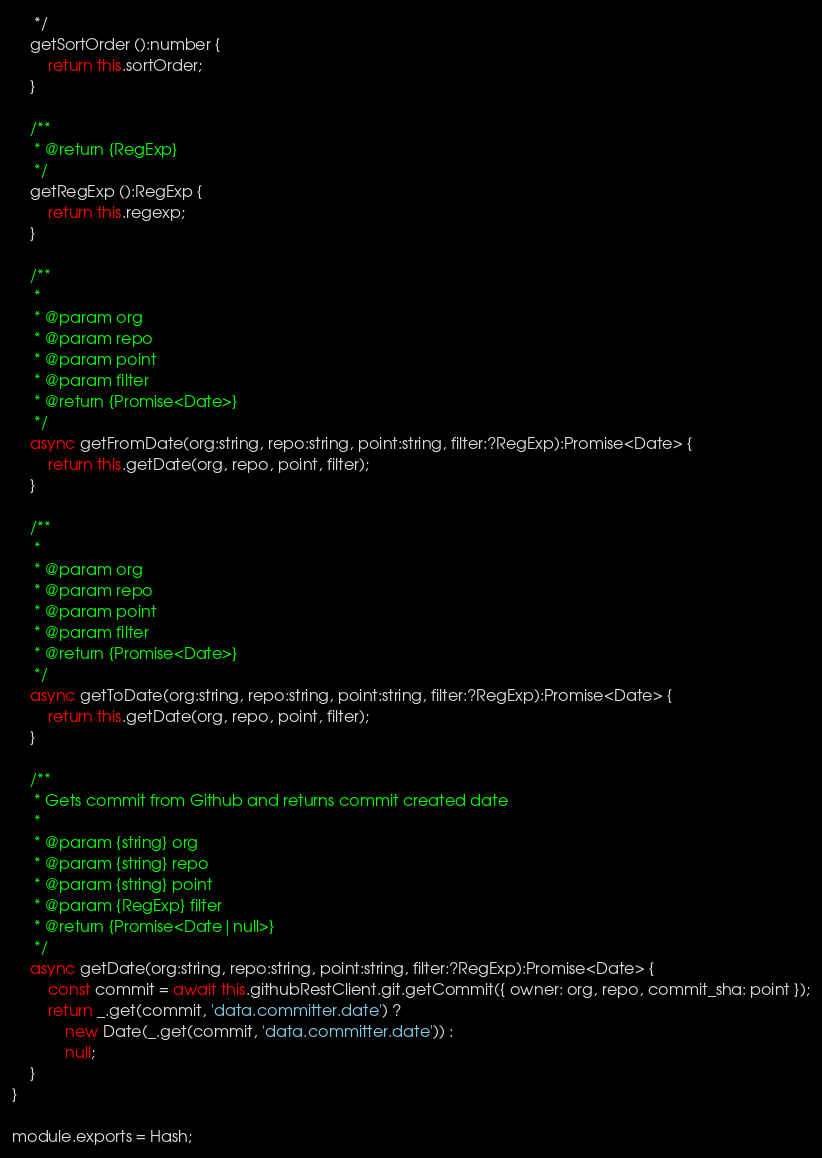<code> <loc_0><loc_0><loc_500><loc_500><_JavaScript_>     */
    getSortOrder ():number {
    	return this.sortOrder;
    }

    /**
     * @return {RegExp}
     */
    getRegExp ():RegExp {
    	return this.regexp;
    }

    /**
     *
     * @param org
     * @param repo
     * @param point
     * @param filter
     * @return {Promise<Date>}
     */
    async getFromDate(org:string, repo:string, point:string, filter:?RegExp):Promise<Date> {
        return this.getDate(org, repo, point, filter);
    }

    /**
     *
     * @param org
     * @param repo
     * @param point
     * @param filter
     * @return {Promise<Date>}
     */
    async getToDate(org:string, repo:string, point:string, filter:?RegExp):Promise<Date> {
        return this.getDate(org, repo, point, filter);
    }

    /**
     * Gets commit from Github and returns commit created date
     *
     * @param {string} org
     * @param {string} repo
     * @param {string} point
     * @param {RegExp} filter
     * @return {Promise<Date|null>}
     */
    async getDate(org:string, repo:string, point:string, filter:?RegExp):Promise<Date> {
    	const commit = await this.githubRestClient.git.getCommit({ owner: org, repo, commit_sha: point });
    	return _.get(commit, 'data.committer.date') ?
    		new Date(_.get(commit, 'data.committer.date')) :
    		null;
    }
}

module.exports = Hash;
</code> 